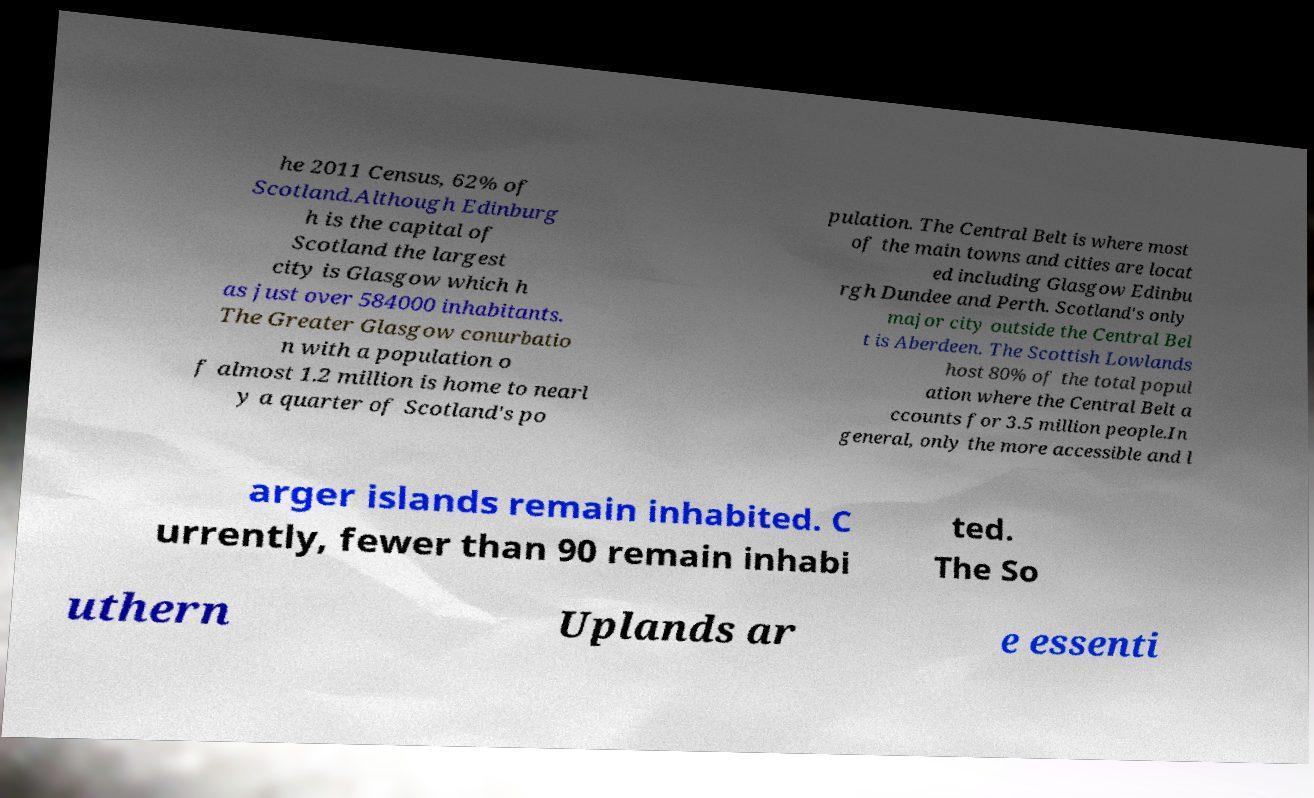Could you extract and type out the text from this image? he 2011 Census, 62% of Scotland.Although Edinburg h is the capital of Scotland the largest city is Glasgow which h as just over 584000 inhabitants. The Greater Glasgow conurbatio n with a population o f almost 1.2 million is home to nearl y a quarter of Scotland's po pulation. The Central Belt is where most of the main towns and cities are locat ed including Glasgow Edinbu rgh Dundee and Perth. Scotland's only major city outside the Central Bel t is Aberdeen. The Scottish Lowlands host 80% of the total popul ation where the Central Belt a ccounts for 3.5 million people.In general, only the more accessible and l arger islands remain inhabited. C urrently, fewer than 90 remain inhabi ted. The So uthern Uplands ar e essenti 